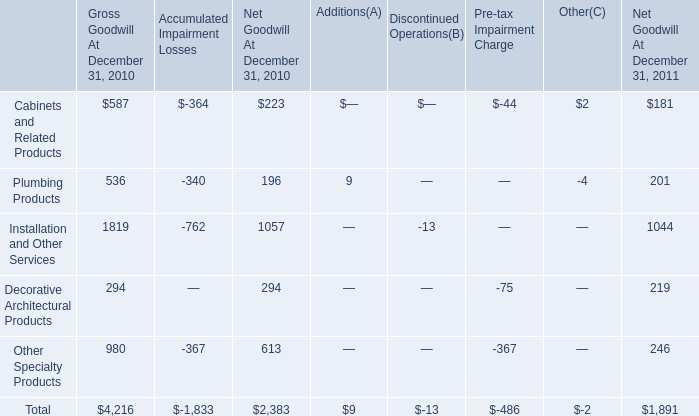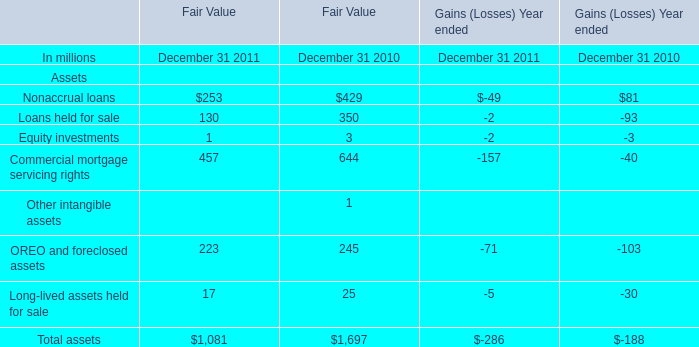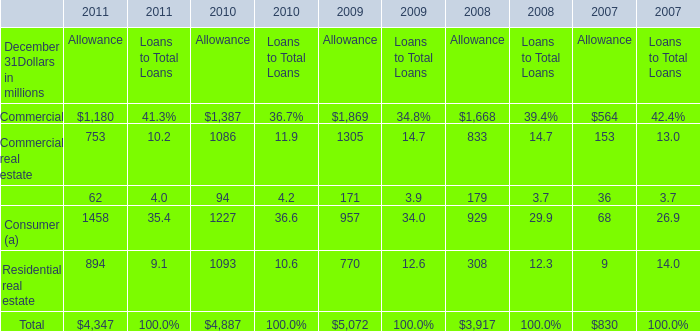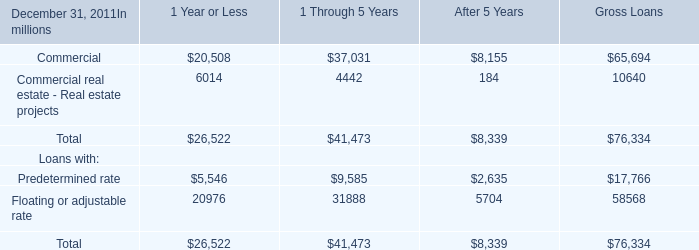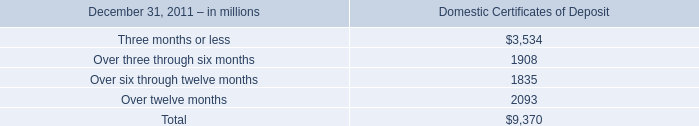How many element exceed the average of Domestic Certificates of Deposit in 2011? 
Answer: 2. 